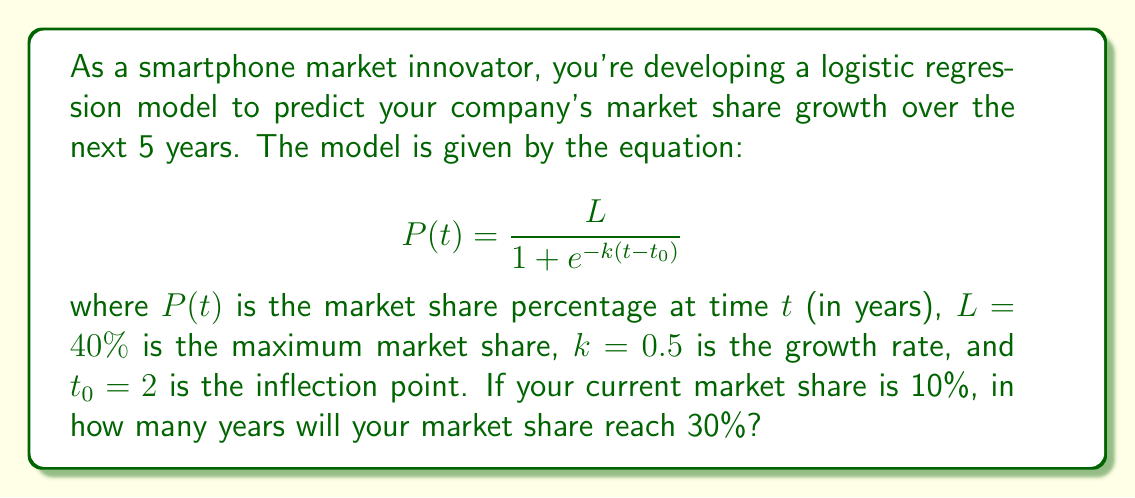Provide a solution to this math problem. To solve this problem, we need to follow these steps:

1) We're looking for the time $t$ when $P(t) = 30\%$. Let's substitute this into our equation:

   $$0.30 = \frac{0.40}{1 + e^{-0.5(t-2)}}$$

2) Multiply both sides by the denominator:

   $$0.30(1 + e^{-0.5(t-2)}) = 0.40$$

3) Expand the left side:

   $$0.30 + 0.30e^{-0.5(t-2)} = 0.40$$

4) Subtract 0.30 from both sides:

   $$0.30e^{-0.5(t-2)} = 0.10$$

5) Divide both sides by 0.30:

   $$e^{-0.5(t-2)} = \frac{1}{3}$$

6) Take the natural log of both sides:

   $$-0.5(t-2) = \ln(\frac{1}{3})$$

7) Multiply both sides by -2:

   $$t-2 = -2\ln(\frac{1}{3})$$

8) Add 2 to both sides:

   $$t = 2 - 2\ln(\frac{1}{3})$$

9) Calculate the final value:

   $$t \approx 4.2$$

Therefore, it will take approximately 4.2 years from the current time to reach a 30% market share.
Answer: 4.2 years 